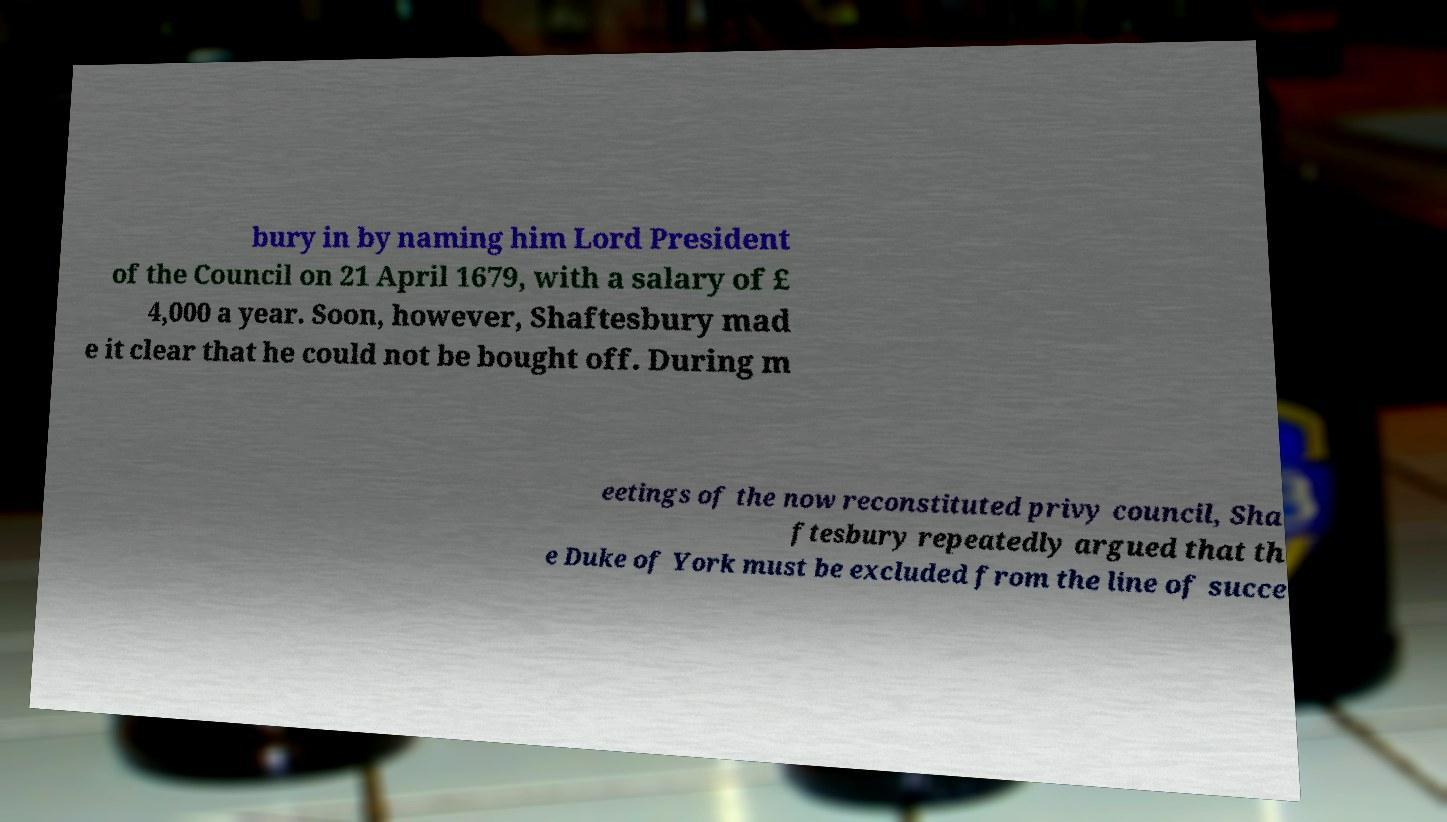Can you accurately transcribe the text from the provided image for me? bury in by naming him Lord President of the Council on 21 April 1679, with a salary of £ 4,000 a year. Soon, however, Shaftesbury mad e it clear that he could not be bought off. During m eetings of the now reconstituted privy council, Sha ftesbury repeatedly argued that th e Duke of York must be excluded from the line of succe 